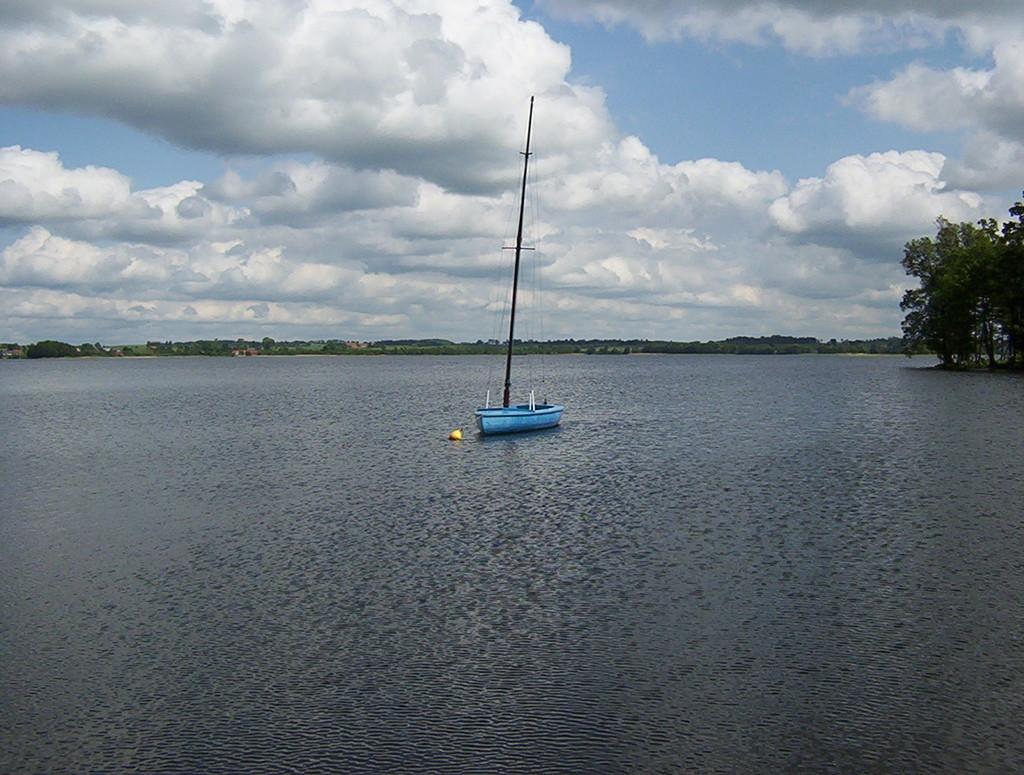Describe this image in one or two sentences. In the center of the image there is boat. At the bottom of the image there is water. In the background of the image there are trees. At the top of the image there is sky and clouds. 